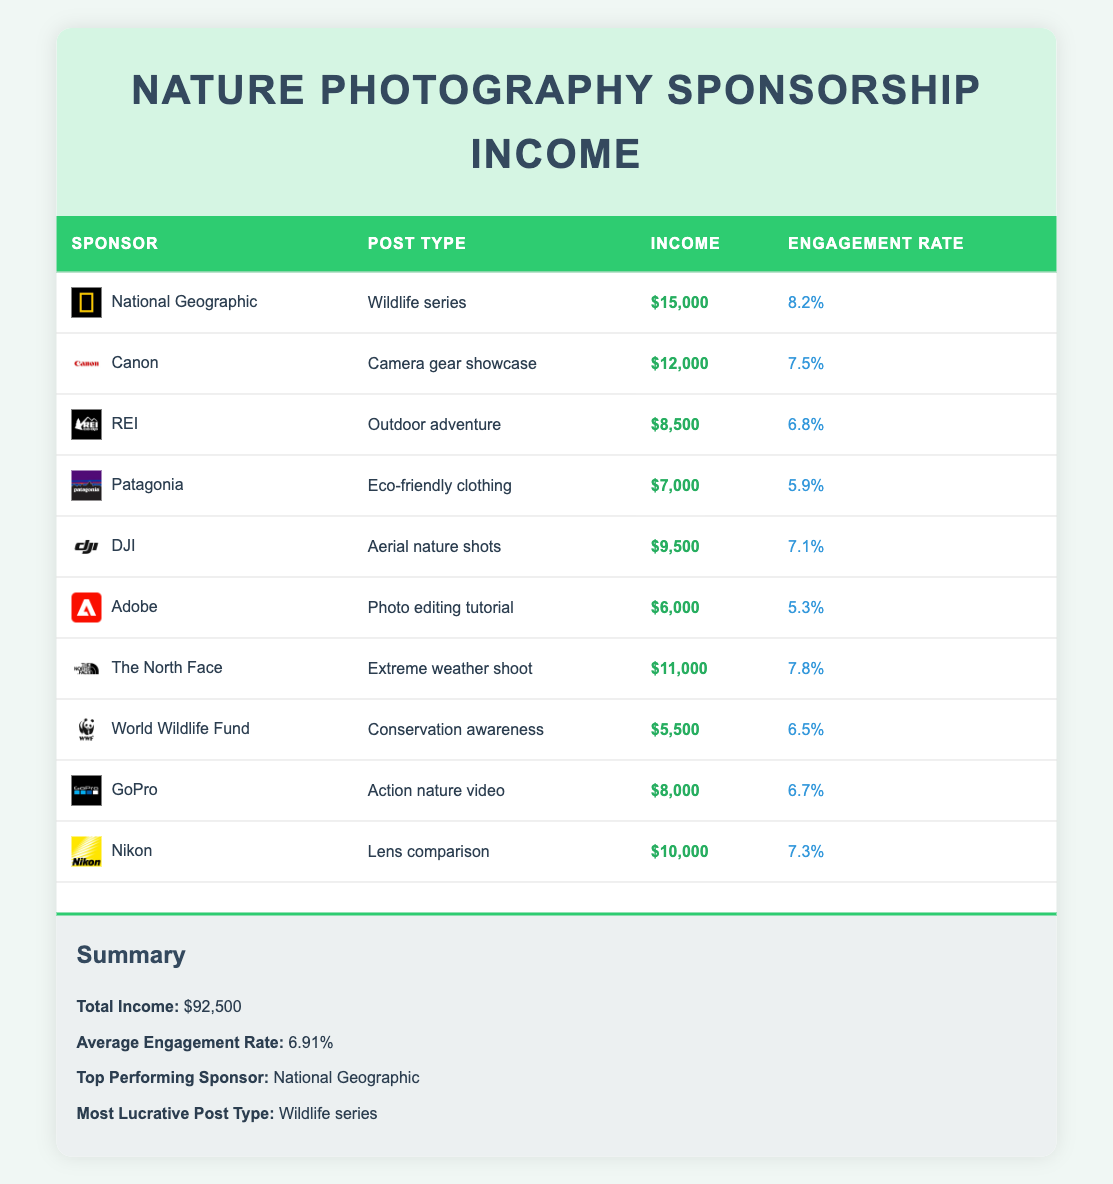What is the total income from sponsored posts? The total income is provided in the summary section of the table, where it indicates "$92,500" as the total.
Answer: 92,500 Which sponsor provided the highest income? By examining the income amounts for each sponsor in the table, National Geographic has the highest income of "$15,000".
Answer: National Geographic What is the engagement rate for the post type "Eco-friendly clothing"? Looking at the row for Patagonia under the "Eco-friendly clothing" post type, the engagement rate is listed as "5.9%".
Answer: 5.9% How many sponsors have an income of over $10,000? From the table, the sponsors with incomes over $10,000 are National Geographic ($15,000), Canon ($12,000), The North Face ($11,000), and Nikon ($10,000), totaling four sponsors.
Answer: 4 What is the average income of all sponsored posts? To find the average income, sum all income values: 15000 + 12000 + 8500 + 7000 + 9500 + 6000 + 11000 + 5500 + 8000 + 10000 = 92500, then divide by the number of sponsors (10) gives: 92500 / 10 = 9250.
Answer: 9250 Is the engagement rate for the "Action nature video" greater than the average engagement rate? The engagement rate for GoPro's "Action nature video" is "6.7%". The average engagement rate is stated as "6.91%." Since 6.7% is less than 6.91%, the statement is false.
Answer: No Which post type has the highest engagement rate? The engagement rates are compared across all post types, and the Wildlife series (National Geographic) has the highest engagement rate of "8.2%".
Answer: Wildlife series What is the total income from sponsors with an engagement rate above 7%? The sponsors above 7% are National Geographic ($15,000), Canon ($12,000), The North Face ($11,000), DJI ($9,500), and Nikon ($10,000). Adding these up: 15000 + 12000 + 11000 + 9500 + 10000 = 57500.
Answer: 57,500 